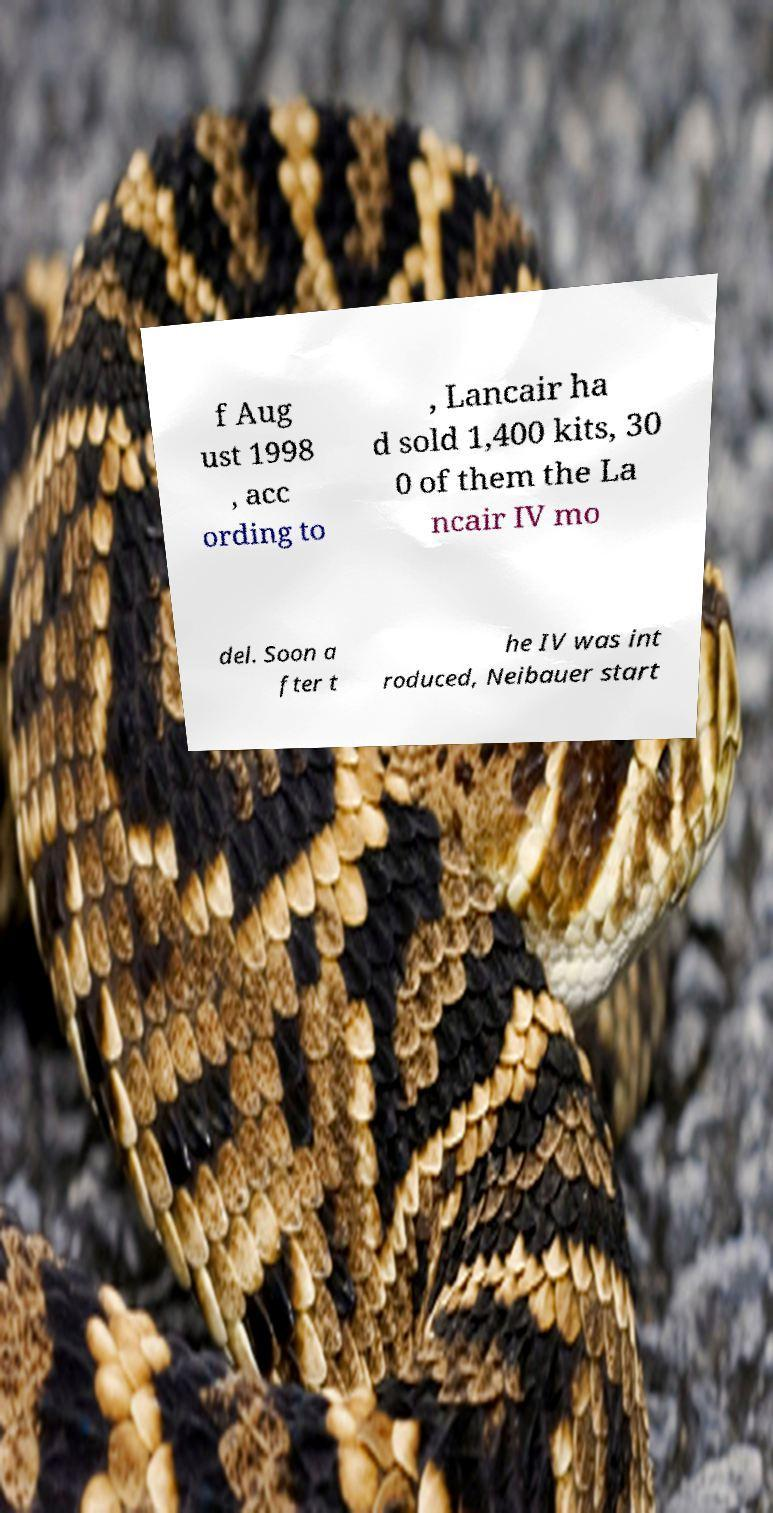Please identify and transcribe the text found in this image. f Aug ust 1998 , acc ording to , Lancair ha d sold 1,400 kits, 30 0 of them the La ncair IV mo del. Soon a fter t he IV was int roduced, Neibauer start 